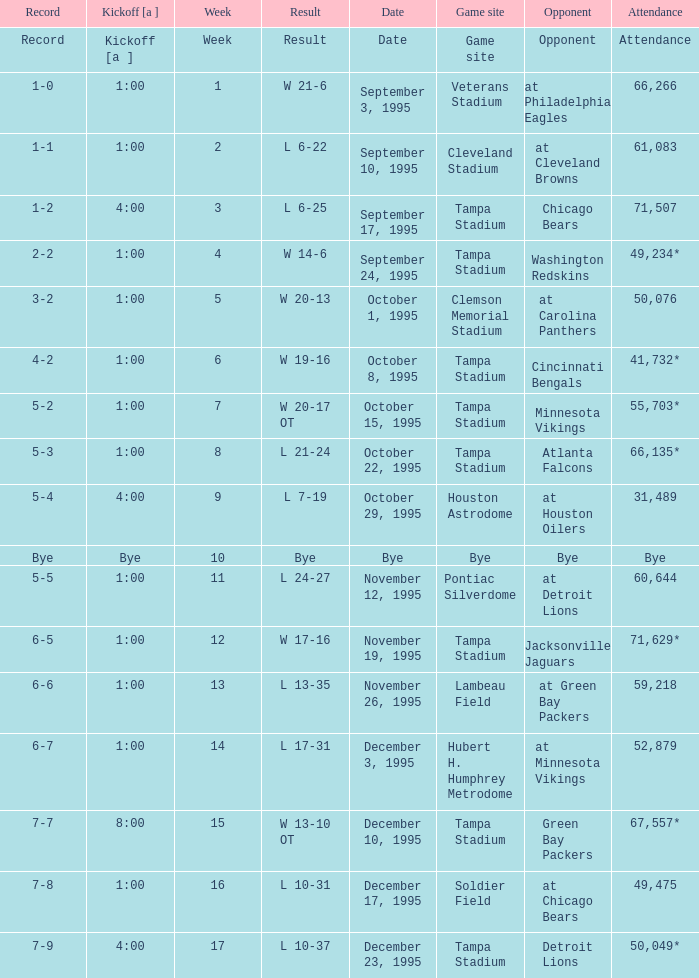On what date was Tampa Bay's Week 4 game? September 24, 1995. 